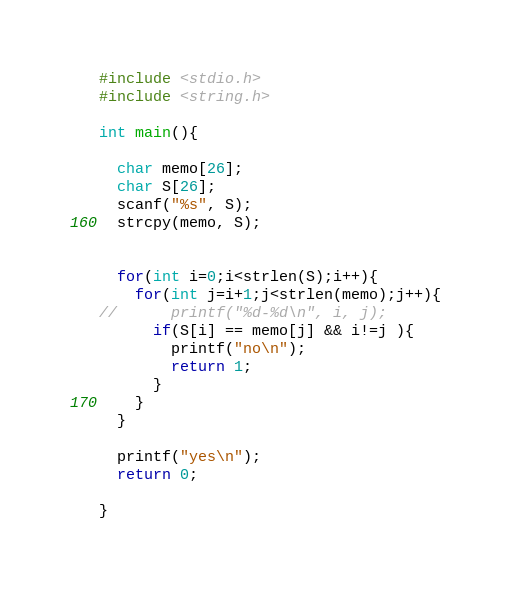<code> <loc_0><loc_0><loc_500><loc_500><_C_>#include <stdio.h>
#include <string.h>
 
int main(){
 
  char memo[26];
  char S[26];
  scanf("%s", S);
  strcpy(memo, S);
 
 
  for(int i=0;i<strlen(S);i++){
    for(int j=i+1;j<strlen(memo);j++){
//      printf("%d-%d\n", i, j);
      if(S[i] == memo[j] && i!=j ){
        printf("no\n");
        return 1;
      }
    }
  }
 
  printf("yes\n");
  return 0;
 
}</code> 